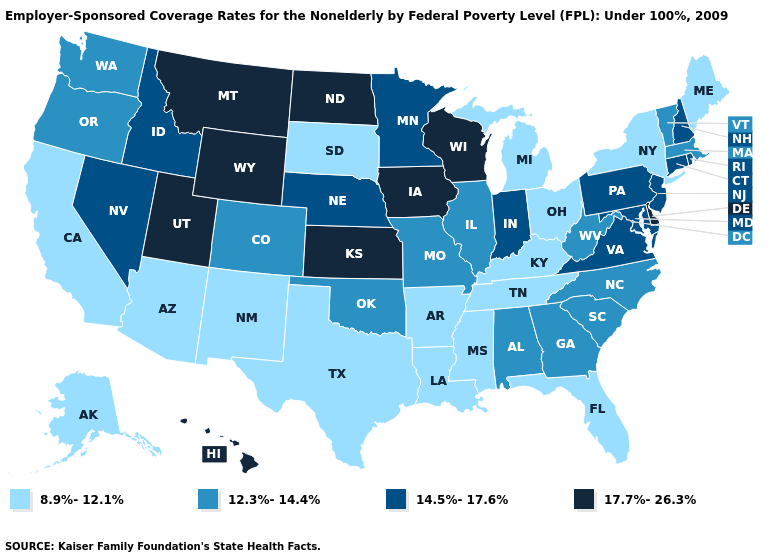Name the states that have a value in the range 12.3%-14.4%?
Give a very brief answer. Alabama, Colorado, Georgia, Illinois, Massachusetts, Missouri, North Carolina, Oklahoma, Oregon, South Carolina, Vermont, Washington, West Virginia. What is the highest value in the West ?
Answer briefly. 17.7%-26.3%. What is the lowest value in the USA?
Concise answer only. 8.9%-12.1%. Does Arizona have a lower value than Maine?
Quick response, please. No. Which states have the lowest value in the USA?
Write a very short answer. Alaska, Arizona, Arkansas, California, Florida, Kentucky, Louisiana, Maine, Michigan, Mississippi, New Mexico, New York, Ohio, South Dakota, Tennessee, Texas. Among the states that border West Virginia , which have the lowest value?
Give a very brief answer. Kentucky, Ohio. Name the states that have a value in the range 17.7%-26.3%?
Be succinct. Delaware, Hawaii, Iowa, Kansas, Montana, North Dakota, Utah, Wisconsin, Wyoming. Among the states that border New Mexico , which have the lowest value?
Keep it brief. Arizona, Texas. Name the states that have a value in the range 8.9%-12.1%?
Short answer required. Alaska, Arizona, Arkansas, California, Florida, Kentucky, Louisiana, Maine, Michigan, Mississippi, New Mexico, New York, Ohio, South Dakota, Tennessee, Texas. Which states hav the highest value in the South?
Quick response, please. Delaware. Name the states that have a value in the range 14.5%-17.6%?
Answer briefly. Connecticut, Idaho, Indiana, Maryland, Minnesota, Nebraska, Nevada, New Hampshire, New Jersey, Pennsylvania, Rhode Island, Virginia. Name the states that have a value in the range 12.3%-14.4%?
Give a very brief answer. Alabama, Colorado, Georgia, Illinois, Massachusetts, Missouri, North Carolina, Oklahoma, Oregon, South Carolina, Vermont, Washington, West Virginia. Does Tennessee have the lowest value in the South?
Quick response, please. Yes. Which states have the lowest value in the MidWest?
Answer briefly. Michigan, Ohio, South Dakota. What is the value of New Jersey?
Give a very brief answer. 14.5%-17.6%. 